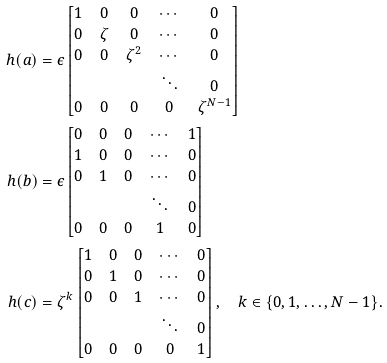<formula> <loc_0><loc_0><loc_500><loc_500>h ( a ) & = \epsilon \begin{bmatrix} 1 & 0 & 0 & \cdots & 0 \\ 0 & \zeta & 0 & \cdots & 0 \\ 0 & 0 & \zeta ^ { 2 } & \cdots & 0 \\ & & & \ddots & 0 \\ 0 & 0 & 0 & 0 & \zeta ^ { N - 1 } \end{bmatrix} \\ h ( b ) & = \epsilon \begin{bmatrix} 0 & 0 & 0 & \cdots & 1 \\ 1 & 0 & 0 & \cdots & 0 \\ 0 & 1 & 0 & \cdots & 0 \\ & & & \ddots & 0 \\ 0 & 0 & 0 & 1 & 0 \end{bmatrix} \\ h ( c ) & = \zeta ^ { k } \begin{bmatrix} 1 & 0 & 0 & \cdots & 0 \\ 0 & 1 & 0 & \cdots & 0 \\ 0 & 0 & 1 & \cdots & 0 \\ & & & \ddots & 0 \\ 0 & 0 & 0 & 0 & 1 \end{bmatrix} , \quad k \in \{ 0 , 1 , \dots , N - 1 \} .</formula> 